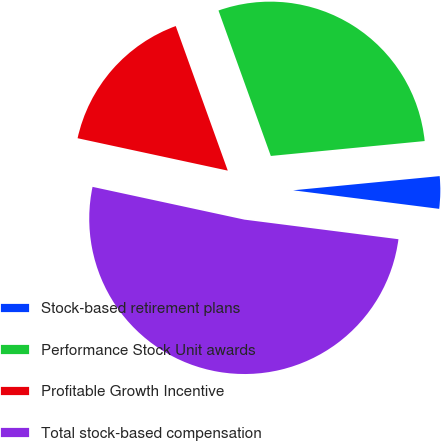<chart> <loc_0><loc_0><loc_500><loc_500><pie_chart><fcel>Stock-based retirement plans<fcel>Performance Stock Unit awards<fcel>Profitable Growth Incentive<fcel>Total stock-based compensation<nl><fcel>3.55%<fcel>28.96%<fcel>16.12%<fcel>51.37%<nl></chart> 